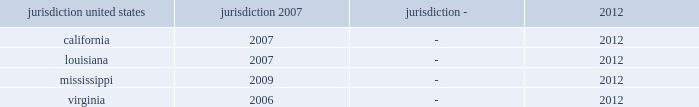As of december 31 , 2012 and 2011 , the estimated value of the company's uncertain tax positions were liabilities of $ 19 million and $ 6 million , respectively .
Assuming sustainment of these positions , the reversal of $ 1 million of the amounts accrued would favorably affect the company's effective federal income tax rate in future periods .
Accrued interest and penalties with respect to unrecognized tax benefits were $ 2 million and $ 3 million as of december 31 , 2012 and 2011 , respectively .
During 2011 , the company recorded a reduction of $ 10 million to its liability for uncertain tax positions relating to tax periods prior to the spin-off for which northrop grumman is the primary obligor .
During 2010 , northrop grumman reached final settlement with the irs and the u .
Congressional joint committee on taxation on the irs examination of northrop grumman's tax returns for the years 2004 through 2006 .
As a result of this settlement , the company recognized tax benefits of $ 8 million as a reduction to the provision for income taxes .
In connection with the settlement , the company also recorded a reduction of $ 10 million to its liability for uncertain tax positions , including previously accrued interest , of $ 2 million .
The table summarizes the tax years that are either currently under examination or remain open under the statute of limitations and subject to examination by the major tax jurisdictions in which the company operates: .
Although the company believes it has adequately provided for all uncertain tax positions , amounts asserted by taxing authorities could be greater than the company's accrued position .
Accordingly , additional provisions on federal and state income tax related matters could be recorded in the future as revised estimates are made or the underlying matters are effectively settled or otherwise resolved .
Conversely , the company could settle positions with the tax authorities for amounts lower than have been accrued .
The company believes it is reasonably possible that during the next 12 months the company's liability for uncertain tax positions may decrease by approximately $ 14 million .
The company recognizes accrued interest and penalties related to uncertain tax positions in income tax expense .
The irs is currently conducting an examination of northrop grumman's consolidated tax returns , of which hii was part , for the years 2007 through 2009 .
Open tax years related to state jurisdictions remain subject to examination .
As of march 31 , 2011 , the date of the spin-off , the company's liability for uncertain tax positions was approximately $ 4 million , net of federal benefit , which related solely to state income tax positions .
Under the terms of the separation agreement , northrop grumman is obligated to reimburse hii for any settlement liabilities paid by hii to any government authority for tax periods prior to the spin-off , which include state income taxes .
Accordingly , the company has recorded a reimbursement receivable of approximately $ 4 million , net of federal benefit , in other assets related to uncertain tax positions for state income taxes as of the date of the spin-off .
Deferred income taxes - deferred income taxes reflect the net tax effects of temporary differences between the carrying amounts of assets and liabilities for financial reporting purposes and income tax purposes .
Such amounts are classified in the consolidated statements of financial position as current or non-current assets or liabilities based upon the classification of the related assets and liabilities. .
How many years of tax examination is the company subject to in mississippi? 
Computations: (2012 - 2009)
Answer: 3.0. 